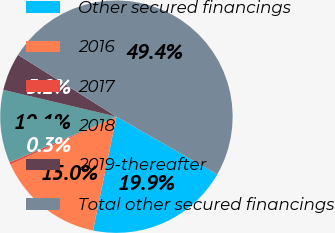<chart> <loc_0><loc_0><loc_500><loc_500><pie_chart><fcel>Other secured financings<fcel>2016<fcel>2017<fcel>2018<fcel>2019-thereafter<fcel>Total other secured financings<nl><fcel>19.94%<fcel>15.03%<fcel>0.32%<fcel>10.13%<fcel>5.23%<fcel>49.36%<nl></chart> 